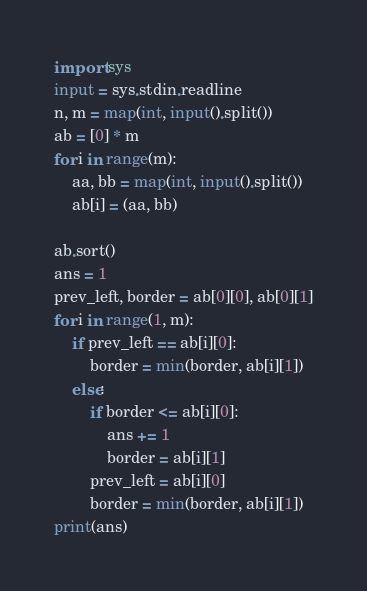Convert code to text. <code><loc_0><loc_0><loc_500><loc_500><_Python_>import sys
input = sys.stdin.readline
n, m = map(int, input().split())
ab = [0] * m
for i in range(m):
    aa, bb = map(int, input().split())
    ab[i] = (aa, bb)

ab.sort()
ans = 1
prev_left, border = ab[0][0], ab[0][1]
for i in range(1, m):
    if prev_left == ab[i][0]:
        border = min(border, ab[i][1])
    else:
        if border <= ab[i][0]:
            ans += 1
            border = ab[i][1]
        prev_left = ab[i][0]
        border = min(border, ab[i][1])
print(ans)</code> 